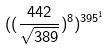Convert formula to latex. <formula><loc_0><loc_0><loc_500><loc_500>( ( \frac { 4 4 2 } { \sqrt { 3 8 9 } } ) ^ { 8 } ) ^ { 3 9 5 ^ { 1 } }</formula> 